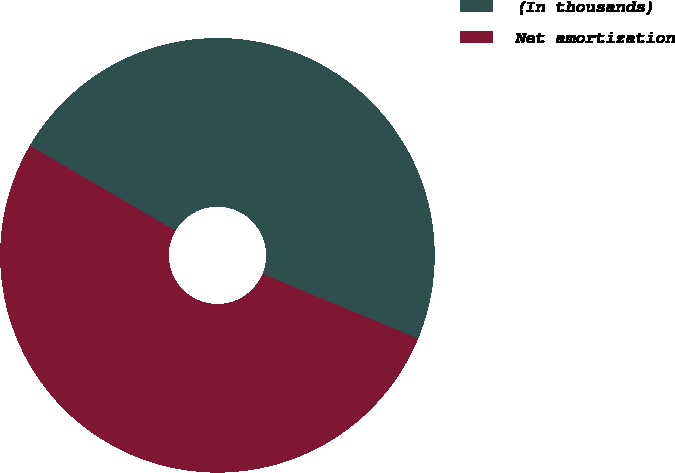<chart> <loc_0><loc_0><loc_500><loc_500><pie_chart><fcel>(In thousands)<fcel>Net amortization<nl><fcel>47.84%<fcel>52.16%<nl></chart> 